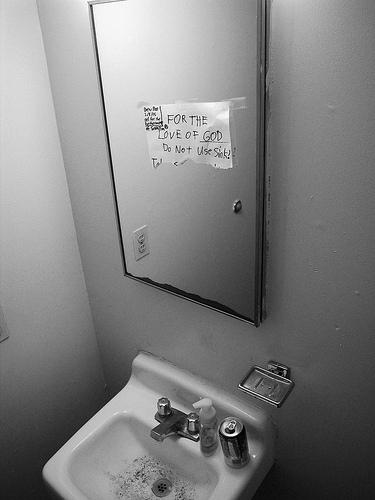Question: where was this picture taken?
Choices:
A. A party.
B. An office.
C. A living room.
D. A bathroom.
Answer with the letter. Answer: D Question: what color are the walls?
Choices:
A. Blue.
B. Gray.
C. Orange.
D. Green.
Answer with the letter. Answer: B Question: how many cans are shown in the picture?
Choices:
A. One.
B. Two.
C. Three.
D. Five.
Answer with the letter. Answer: A Question: how many outlets does the electrical outlet have?
Choices:
A. Four.
B. Two.
C. Three.
D. Six.
Answer with the letter. Answer: B Question: where was this photo taken?
Choices:
A. In a park.
B. In the woods.
C. United States.
D. At an office.
Answer with the letter. Answer: C 